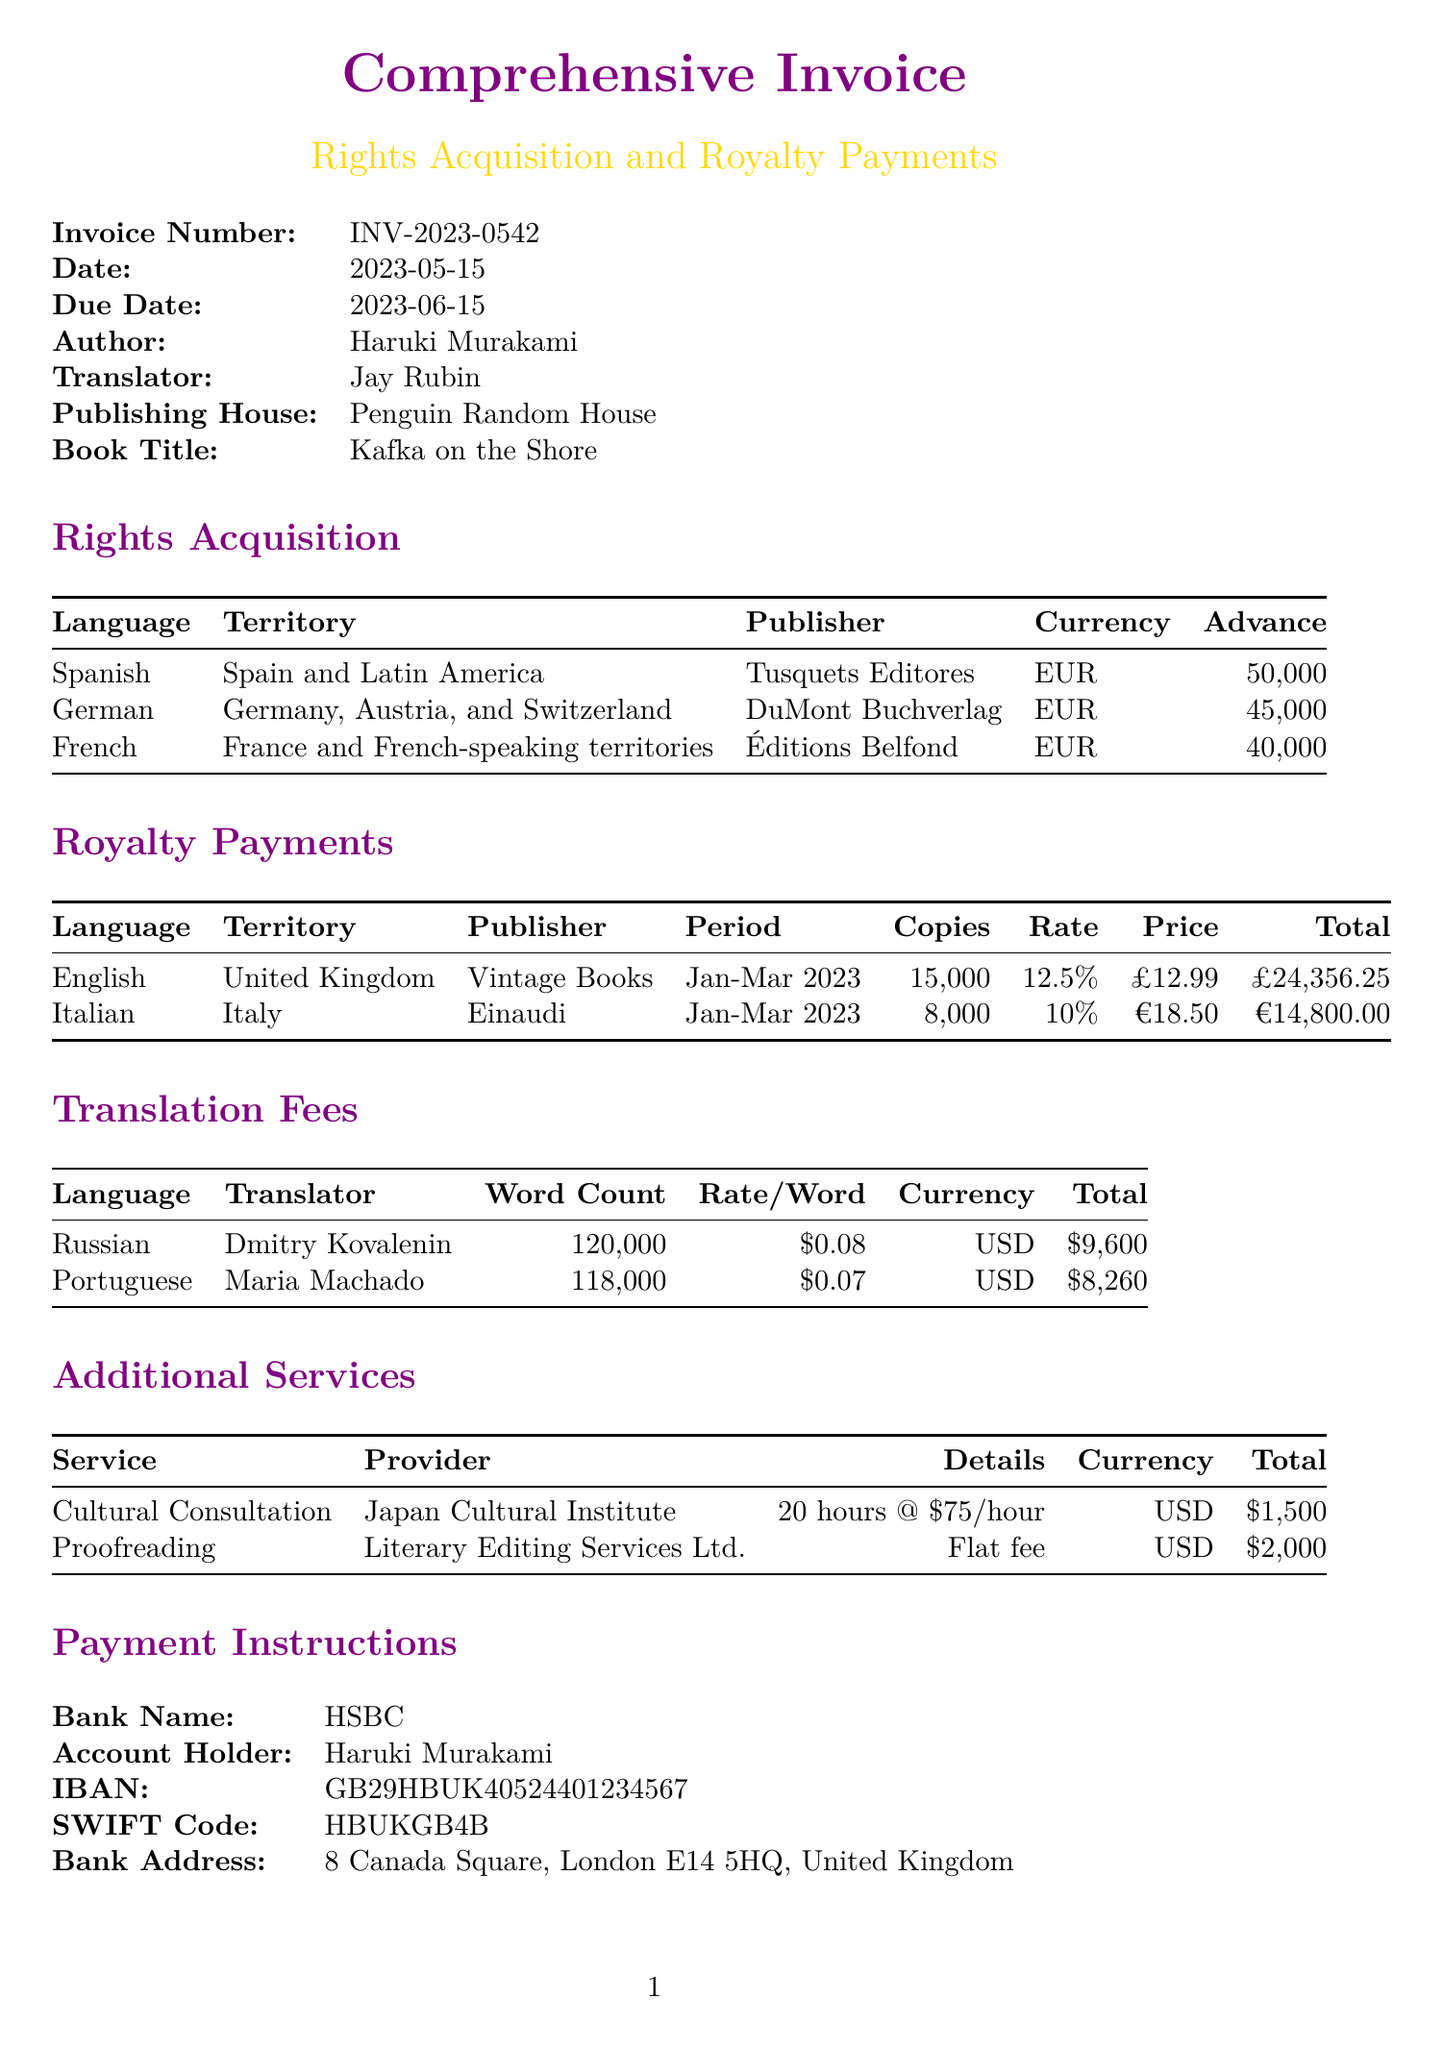What is the invoice number? The invoice number is clearly stated in the document for identification purposes.
Answer: INV-2023-0542 Who is the author? The author's name is mentioned in the opening section of the invoice.
Answer: Haruki Murakami What is the advance for Spanish rights acquisition? The advance for Spanish rights is listed under the rights acquisition section.
Answer: 50000 EUR How many copies of the book were sold in the UK? The number of copies sold is specified in the royalty payments section for the UK.
Answer: 15000 What is the total royalty for the Italian publisher? The total royalty for the Italian publisher is provided in the royalty payments table.
Answer: 14800 EUR What is the currency for the translation fee for Russian? The currency for the translation fee is noted next to the relevant fee in the translation fees section.
Answer: USD What services are included under additional services? The document lists the additional services provided along with their details.
Answer: Cultural Consultation, Proofreading What is the total fee for proofreading? The total fee is clearly stated in the additional services section.
Answer: 2000 USD What is the payment due date? The due date is specified in the invoice details section.
Answer: 2023-06-15 